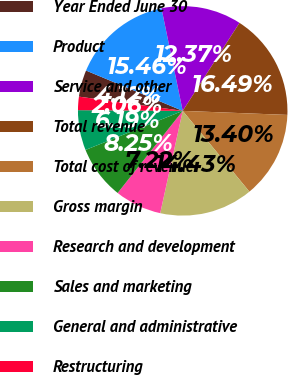<chart> <loc_0><loc_0><loc_500><loc_500><pie_chart><fcel>Year Ended June 30<fcel>Product<fcel>Service and other<fcel>Total revenue<fcel>Total cost of revenue<fcel>Gross margin<fcel>Research and development<fcel>Sales and marketing<fcel>General and administrative<fcel>Restructuring<nl><fcel>4.12%<fcel>15.46%<fcel>12.37%<fcel>16.49%<fcel>13.4%<fcel>14.43%<fcel>7.22%<fcel>8.25%<fcel>6.19%<fcel>2.06%<nl></chart> 